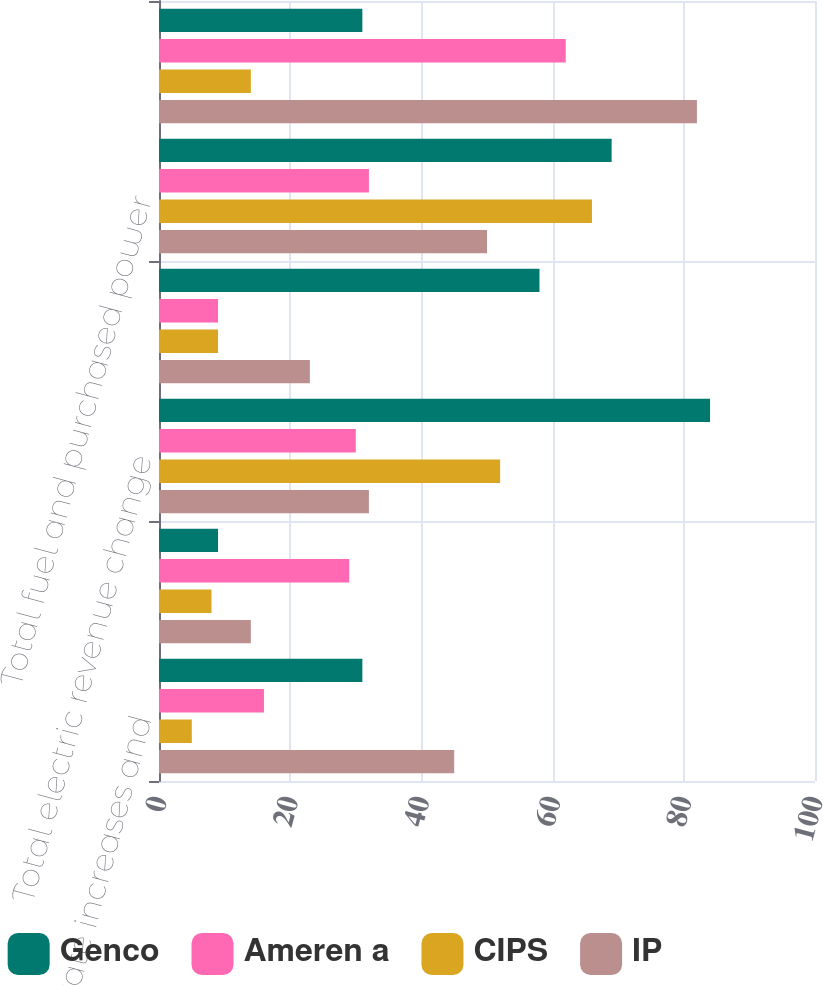<chart> <loc_0><loc_0><loc_500><loc_500><stacked_bar_chart><ecel><fcel>Electric rate increases and<fcel>Generation output and other<fcel>Total electric revenue change<fcel>Purchased power<fcel>Total fuel and purchased power<fcel>Net change in electric margins<nl><fcel>Genco<fcel>31<fcel>9<fcel>84<fcel>58<fcel>69<fcel>31<nl><fcel>Ameren a<fcel>16<fcel>29<fcel>30<fcel>9<fcel>32<fcel>62<nl><fcel>CIPS<fcel>5<fcel>8<fcel>52<fcel>9<fcel>66<fcel>14<nl><fcel>IP<fcel>45<fcel>14<fcel>32<fcel>23<fcel>50<fcel>82<nl></chart> 